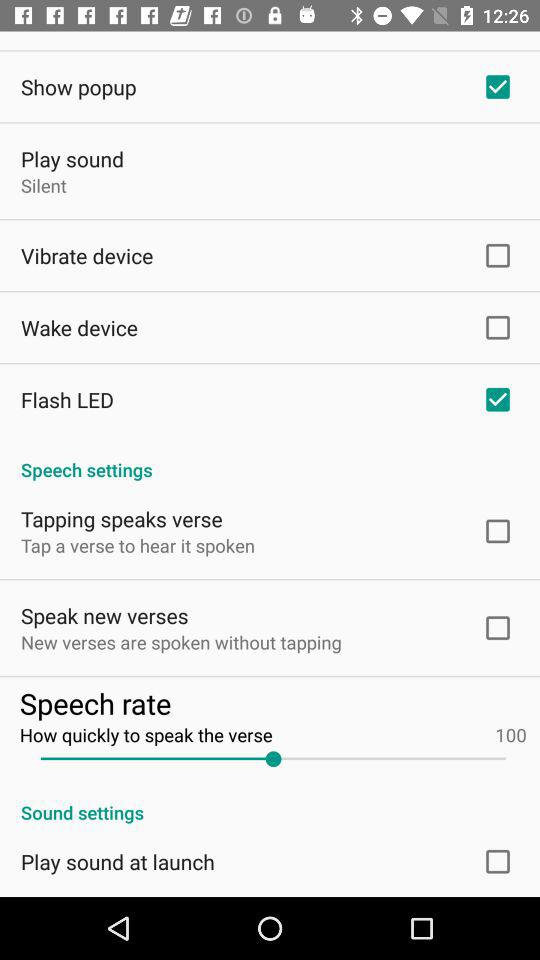What is the name of the application?
When the provided information is insufficient, respond with <no answer>. <no answer> 